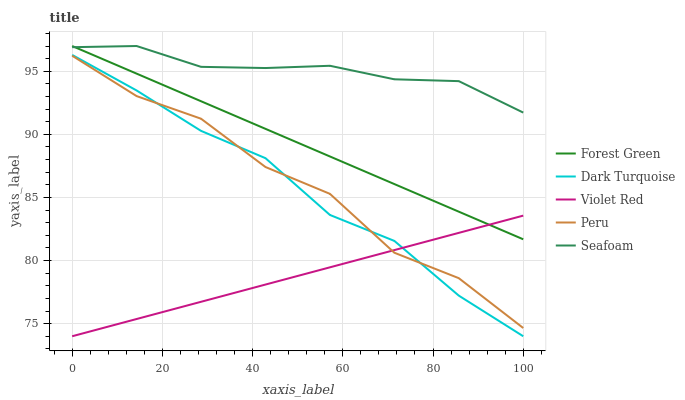Does Violet Red have the minimum area under the curve?
Answer yes or no. Yes. Does Seafoam have the maximum area under the curve?
Answer yes or no. Yes. Does Forest Green have the minimum area under the curve?
Answer yes or no. No. Does Forest Green have the maximum area under the curve?
Answer yes or no. No. Is Violet Red the smoothest?
Answer yes or no. Yes. Is Peru the roughest?
Answer yes or no. Yes. Is Forest Green the smoothest?
Answer yes or no. No. Is Forest Green the roughest?
Answer yes or no. No. Does Dark Turquoise have the lowest value?
Answer yes or no. Yes. Does Forest Green have the lowest value?
Answer yes or no. No. Does Seafoam have the highest value?
Answer yes or no. Yes. Does Violet Red have the highest value?
Answer yes or no. No. Is Dark Turquoise less than Forest Green?
Answer yes or no. Yes. Is Seafoam greater than Dark Turquoise?
Answer yes or no. Yes. Does Violet Red intersect Forest Green?
Answer yes or no. Yes. Is Violet Red less than Forest Green?
Answer yes or no. No. Is Violet Red greater than Forest Green?
Answer yes or no. No. Does Dark Turquoise intersect Forest Green?
Answer yes or no. No. 